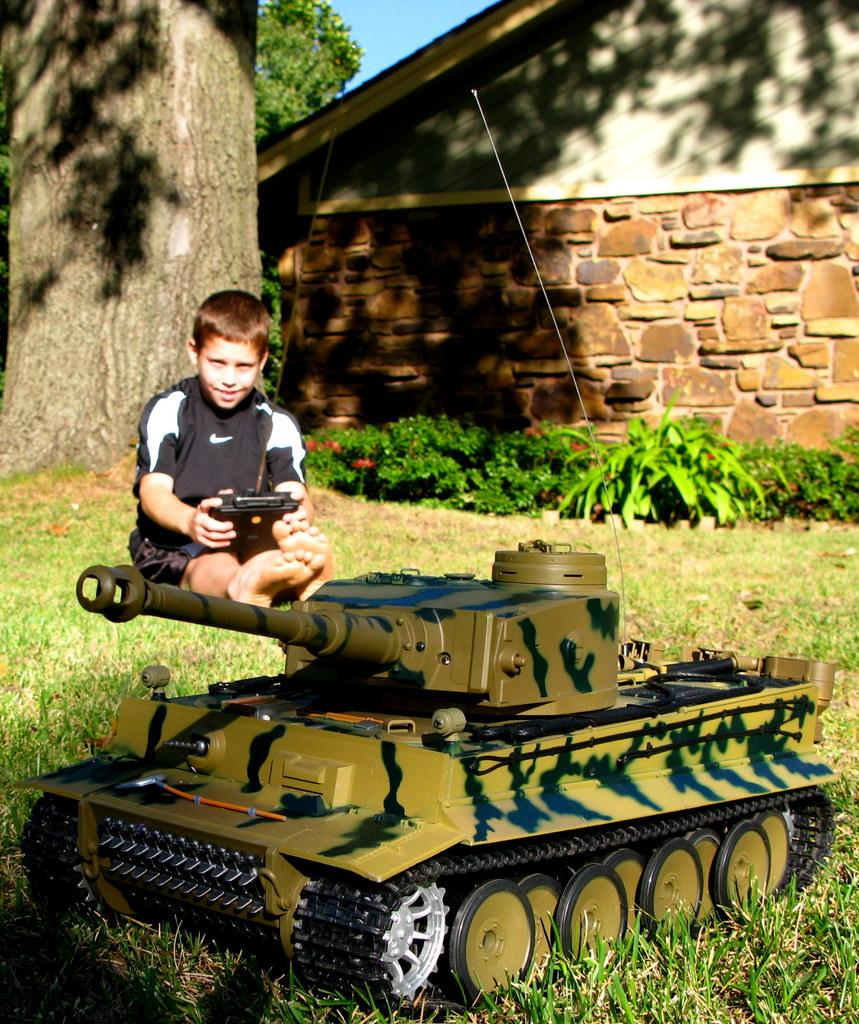Who is present in the image? There is a boy in the image. What is the boy doing in the image? The boy is sitting on the grassland and playing with a toy. What can be seen in the background of the image? There are plants, a tree, and a wall in the background of the image. What type of stamp can be seen on the boy's toy in the image? There is no stamp visible on the boy's toy in the image. What color is the pencil that the boy is using to draw on the wall in the image? There is no pencil or drawing on the wall in the image. 